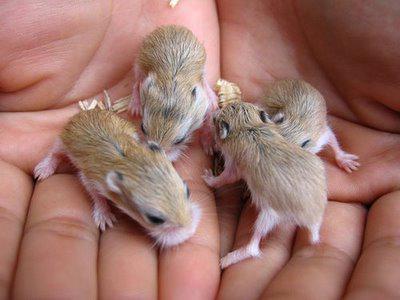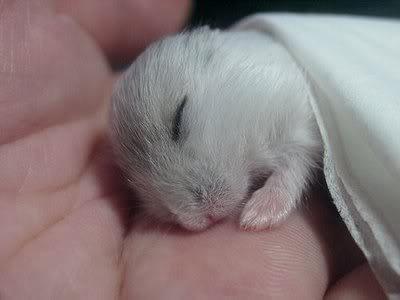The first image is the image on the left, the second image is the image on the right. Examine the images to the left and right. Is the description "There is exactly one sleeping rodent in the hand of a human in the image on the right." accurate? Answer yes or no. Yes. 